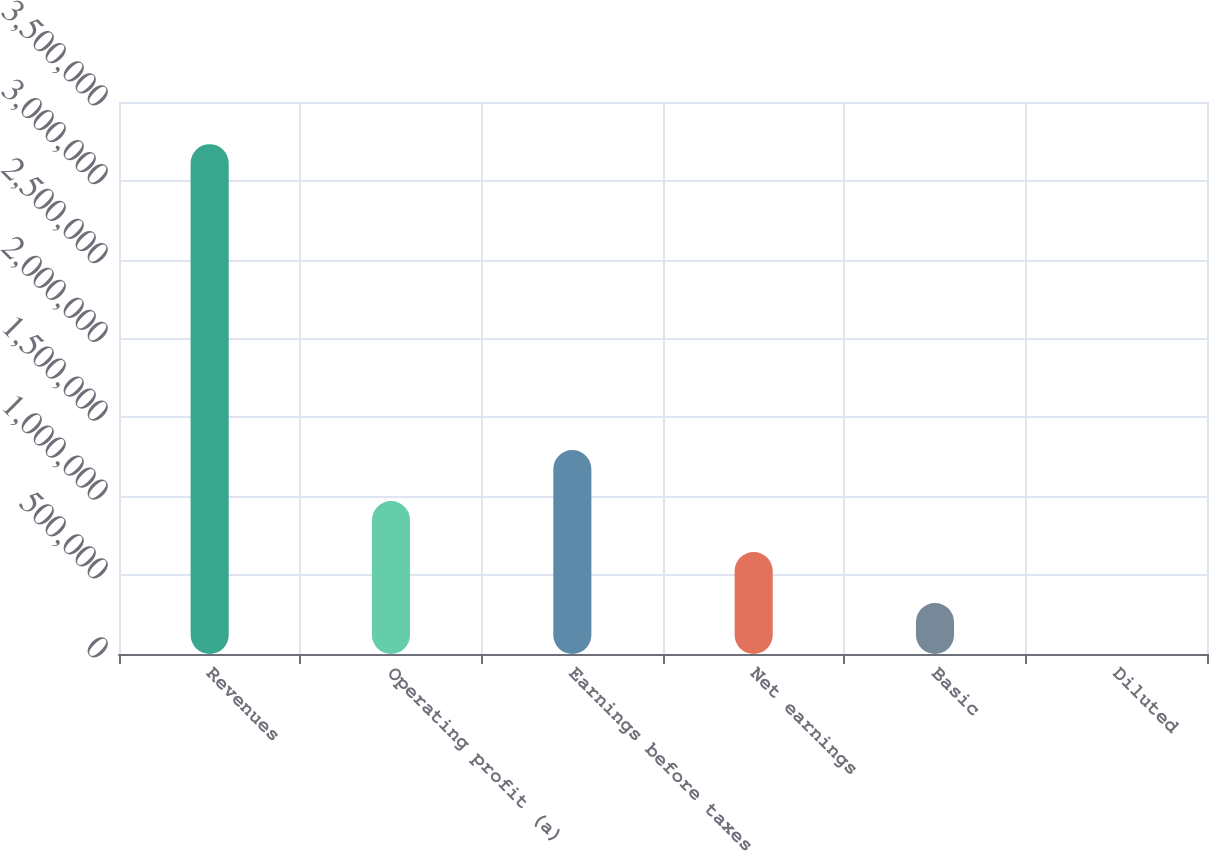Convert chart. <chart><loc_0><loc_0><loc_500><loc_500><bar_chart><fcel>Revenues<fcel>Operating profit (a)<fcel>Earnings before taxes<fcel>Net earnings<fcel>Basic<fcel>Diluted<nl><fcel>3.23265e+06<fcel>969797<fcel>1.29306e+06<fcel>646531<fcel>323266<fcel>0.94<nl></chart> 